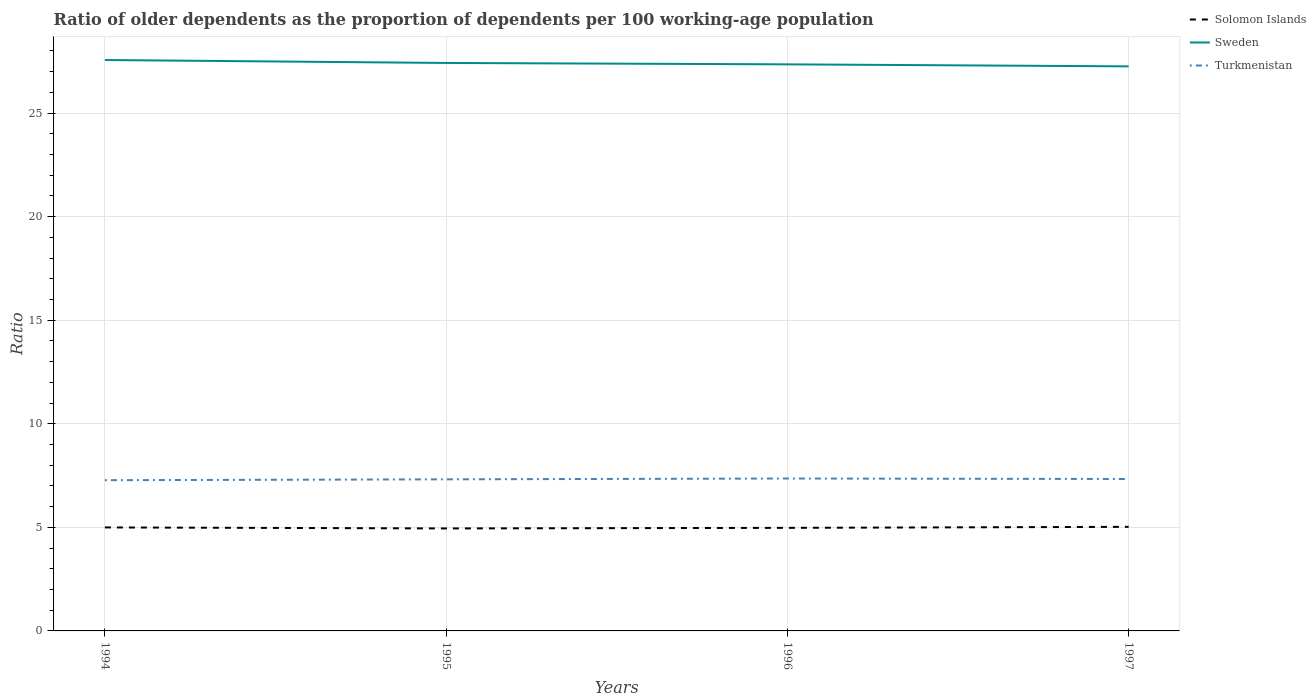How many different coloured lines are there?
Offer a very short reply. 3. Does the line corresponding to Turkmenistan intersect with the line corresponding to Solomon Islands?
Make the answer very short. No. Is the number of lines equal to the number of legend labels?
Make the answer very short. Yes. Across all years, what is the maximum age dependency ratio(old) in Solomon Islands?
Offer a very short reply. 4.95. In which year was the age dependency ratio(old) in Turkmenistan maximum?
Your response must be concise. 1994. What is the total age dependency ratio(old) in Turkmenistan in the graph?
Provide a succinct answer. -0.08. What is the difference between the highest and the second highest age dependency ratio(old) in Turkmenistan?
Offer a terse response. 0.08. What is the difference between the highest and the lowest age dependency ratio(old) in Solomon Islands?
Offer a terse response. 2. How many years are there in the graph?
Provide a short and direct response. 4. What is the difference between two consecutive major ticks on the Y-axis?
Your answer should be very brief. 5. Are the values on the major ticks of Y-axis written in scientific E-notation?
Offer a terse response. No. Does the graph contain any zero values?
Your answer should be compact. No. How many legend labels are there?
Offer a terse response. 3. How are the legend labels stacked?
Provide a succinct answer. Vertical. What is the title of the graph?
Provide a short and direct response. Ratio of older dependents as the proportion of dependents per 100 working-age population. What is the label or title of the Y-axis?
Ensure brevity in your answer.  Ratio. What is the Ratio in Solomon Islands in 1994?
Keep it short and to the point. 5. What is the Ratio of Sweden in 1994?
Ensure brevity in your answer.  27.56. What is the Ratio of Turkmenistan in 1994?
Offer a terse response. 7.28. What is the Ratio in Solomon Islands in 1995?
Offer a terse response. 4.95. What is the Ratio of Sweden in 1995?
Keep it short and to the point. 27.42. What is the Ratio of Turkmenistan in 1995?
Provide a short and direct response. 7.32. What is the Ratio of Solomon Islands in 1996?
Ensure brevity in your answer.  4.98. What is the Ratio of Sweden in 1996?
Offer a terse response. 27.35. What is the Ratio of Turkmenistan in 1996?
Provide a succinct answer. 7.36. What is the Ratio of Solomon Islands in 1997?
Offer a very short reply. 5.03. What is the Ratio in Sweden in 1997?
Give a very brief answer. 27.26. What is the Ratio in Turkmenistan in 1997?
Keep it short and to the point. 7.33. Across all years, what is the maximum Ratio of Solomon Islands?
Keep it short and to the point. 5.03. Across all years, what is the maximum Ratio in Sweden?
Your answer should be compact. 27.56. Across all years, what is the maximum Ratio in Turkmenistan?
Your answer should be compact. 7.36. Across all years, what is the minimum Ratio in Solomon Islands?
Make the answer very short. 4.95. Across all years, what is the minimum Ratio in Sweden?
Your answer should be very brief. 27.26. Across all years, what is the minimum Ratio in Turkmenistan?
Make the answer very short. 7.28. What is the total Ratio in Solomon Islands in the graph?
Keep it short and to the point. 19.95. What is the total Ratio in Sweden in the graph?
Your answer should be very brief. 109.59. What is the total Ratio in Turkmenistan in the graph?
Your response must be concise. 29.29. What is the difference between the Ratio of Solomon Islands in 1994 and that in 1995?
Keep it short and to the point. 0.05. What is the difference between the Ratio of Sweden in 1994 and that in 1995?
Offer a very short reply. 0.14. What is the difference between the Ratio of Turkmenistan in 1994 and that in 1995?
Keep it short and to the point. -0.04. What is the difference between the Ratio of Solomon Islands in 1994 and that in 1996?
Provide a succinct answer. 0.02. What is the difference between the Ratio of Sweden in 1994 and that in 1996?
Give a very brief answer. 0.21. What is the difference between the Ratio in Turkmenistan in 1994 and that in 1996?
Offer a very short reply. -0.08. What is the difference between the Ratio in Solomon Islands in 1994 and that in 1997?
Make the answer very short. -0.03. What is the difference between the Ratio of Sweden in 1994 and that in 1997?
Your response must be concise. 0.31. What is the difference between the Ratio in Turkmenistan in 1994 and that in 1997?
Your response must be concise. -0.06. What is the difference between the Ratio in Solomon Islands in 1995 and that in 1996?
Keep it short and to the point. -0.03. What is the difference between the Ratio of Sweden in 1995 and that in 1996?
Give a very brief answer. 0.07. What is the difference between the Ratio of Turkmenistan in 1995 and that in 1996?
Offer a very short reply. -0.04. What is the difference between the Ratio of Solomon Islands in 1995 and that in 1997?
Make the answer very short. -0.08. What is the difference between the Ratio in Sweden in 1995 and that in 1997?
Your response must be concise. 0.16. What is the difference between the Ratio in Turkmenistan in 1995 and that in 1997?
Your answer should be very brief. -0.02. What is the difference between the Ratio of Solomon Islands in 1996 and that in 1997?
Your answer should be very brief. -0.05. What is the difference between the Ratio in Sweden in 1996 and that in 1997?
Ensure brevity in your answer.  0.1. What is the difference between the Ratio of Turkmenistan in 1996 and that in 1997?
Make the answer very short. 0.02. What is the difference between the Ratio of Solomon Islands in 1994 and the Ratio of Sweden in 1995?
Give a very brief answer. -22.42. What is the difference between the Ratio in Solomon Islands in 1994 and the Ratio in Turkmenistan in 1995?
Provide a succinct answer. -2.32. What is the difference between the Ratio of Sweden in 1994 and the Ratio of Turkmenistan in 1995?
Offer a terse response. 20.24. What is the difference between the Ratio in Solomon Islands in 1994 and the Ratio in Sweden in 1996?
Provide a succinct answer. -22.36. What is the difference between the Ratio of Solomon Islands in 1994 and the Ratio of Turkmenistan in 1996?
Make the answer very short. -2.36. What is the difference between the Ratio in Sweden in 1994 and the Ratio in Turkmenistan in 1996?
Give a very brief answer. 20.2. What is the difference between the Ratio in Solomon Islands in 1994 and the Ratio in Sweden in 1997?
Your response must be concise. -22.26. What is the difference between the Ratio of Solomon Islands in 1994 and the Ratio of Turkmenistan in 1997?
Keep it short and to the point. -2.34. What is the difference between the Ratio in Sweden in 1994 and the Ratio in Turkmenistan in 1997?
Provide a succinct answer. 20.23. What is the difference between the Ratio of Solomon Islands in 1995 and the Ratio of Sweden in 1996?
Provide a succinct answer. -22.41. What is the difference between the Ratio of Solomon Islands in 1995 and the Ratio of Turkmenistan in 1996?
Your response must be concise. -2.41. What is the difference between the Ratio in Sweden in 1995 and the Ratio in Turkmenistan in 1996?
Provide a succinct answer. 20.06. What is the difference between the Ratio of Solomon Islands in 1995 and the Ratio of Sweden in 1997?
Your answer should be very brief. -22.31. What is the difference between the Ratio of Solomon Islands in 1995 and the Ratio of Turkmenistan in 1997?
Provide a short and direct response. -2.39. What is the difference between the Ratio of Sweden in 1995 and the Ratio of Turkmenistan in 1997?
Ensure brevity in your answer.  20.09. What is the difference between the Ratio in Solomon Islands in 1996 and the Ratio in Sweden in 1997?
Keep it short and to the point. -22.28. What is the difference between the Ratio of Solomon Islands in 1996 and the Ratio of Turkmenistan in 1997?
Offer a terse response. -2.36. What is the difference between the Ratio in Sweden in 1996 and the Ratio in Turkmenistan in 1997?
Give a very brief answer. 20.02. What is the average Ratio of Solomon Islands per year?
Your answer should be very brief. 4.99. What is the average Ratio of Sweden per year?
Keep it short and to the point. 27.4. What is the average Ratio of Turkmenistan per year?
Provide a short and direct response. 7.32. In the year 1994, what is the difference between the Ratio in Solomon Islands and Ratio in Sweden?
Offer a terse response. -22.57. In the year 1994, what is the difference between the Ratio of Solomon Islands and Ratio of Turkmenistan?
Your response must be concise. -2.28. In the year 1994, what is the difference between the Ratio in Sweden and Ratio in Turkmenistan?
Provide a short and direct response. 20.29. In the year 1995, what is the difference between the Ratio of Solomon Islands and Ratio of Sweden?
Provide a succinct answer. -22.47. In the year 1995, what is the difference between the Ratio of Solomon Islands and Ratio of Turkmenistan?
Provide a short and direct response. -2.37. In the year 1995, what is the difference between the Ratio of Sweden and Ratio of Turkmenistan?
Make the answer very short. 20.1. In the year 1996, what is the difference between the Ratio of Solomon Islands and Ratio of Sweden?
Your answer should be compact. -22.38. In the year 1996, what is the difference between the Ratio in Solomon Islands and Ratio in Turkmenistan?
Ensure brevity in your answer.  -2.38. In the year 1996, what is the difference between the Ratio of Sweden and Ratio of Turkmenistan?
Your response must be concise. 19.99. In the year 1997, what is the difference between the Ratio in Solomon Islands and Ratio in Sweden?
Offer a terse response. -22.23. In the year 1997, what is the difference between the Ratio in Solomon Islands and Ratio in Turkmenistan?
Your answer should be very brief. -2.31. In the year 1997, what is the difference between the Ratio in Sweden and Ratio in Turkmenistan?
Offer a very short reply. 19.92. What is the ratio of the Ratio in Solomon Islands in 1994 to that in 1995?
Make the answer very short. 1.01. What is the ratio of the Ratio in Turkmenistan in 1994 to that in 1995?
Keep it short and to the point. 0.99. What is the ratio of the Ratio of Sweden in 1994 to that in 1996?
Keep it short and to the point. 1.01. What is the ratio of the Ratio of Turkmenistan in 1994 to that in 1996?
Your answer should be very brief. 0.99. What is the ratio of the Ratio in Sweden in 1994 to that in 1997?
Your response must be concise. 1.01. What is the ratio of the Ratio in Turkmenistan in 1994 to that in 1997?
Ensure brevity in your answer.  0.99. What is the ratio of the Ratio in Sweden in 1995 to that in 1996?
Offer a terse response. 1. What is the ratio of the Ratio of Turkmenistan in 1995 to that in 1996?
Ensure brevity in your answer.  0.99. What is the ratio of the Ratio in Solomon Islands in 1995 to that in 1997?
Make the answer very short. 0.98. What is the ratio of the Ratio in Sweden in 1995 to that in 1997?
Provide a short and direct response. 1.01. What is the ratio of the Ratio of Turkmenistan in 1995 to that in 1997?
Ensure brevity in your answer.  1. What is the ratio of the Ratio in Solomon Islands in 1996 to that in 1997?
Your answer should be compact. 0.99. What is the ratio of the Ratio of Sweden in 1996 to that in 1997?
Offer a terse response. 1. What is the difference between the highest and the second highest Ratio in Solomon Islands?
Provide a short and direct response. 0.03. What is the difference between the highest and the second highest Ratio in Sweden?
Your answer should be compact. 0.14. What is the difference between the highest and the second highest Ratio in Turkmenistan?
Offer a terse response. 0.02. What is the difference between the highest and the lowest Ratio in Solomon Islands?
Offer a terse response. 0.08. What is the difference between the highest and the lowest Ratio in Sweden?
Provide a succinct answer. 0.31. What is the difference between the highest and the lowest Ratio of Turkmenistan?
Ensure brevity in your answer.  0.08. 